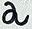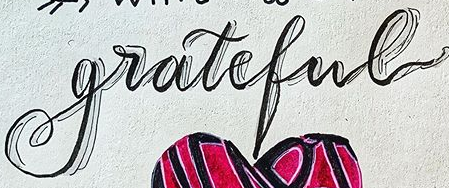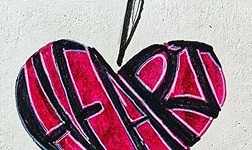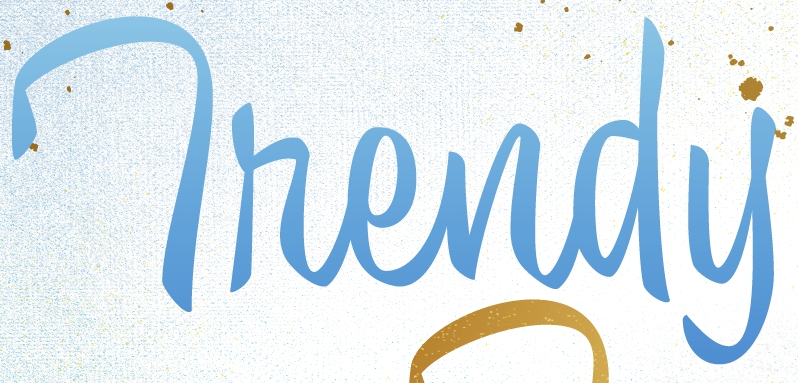Identify the words shown in these images in order, separated by a semicolon. a; grateful; HFART; Thendy 